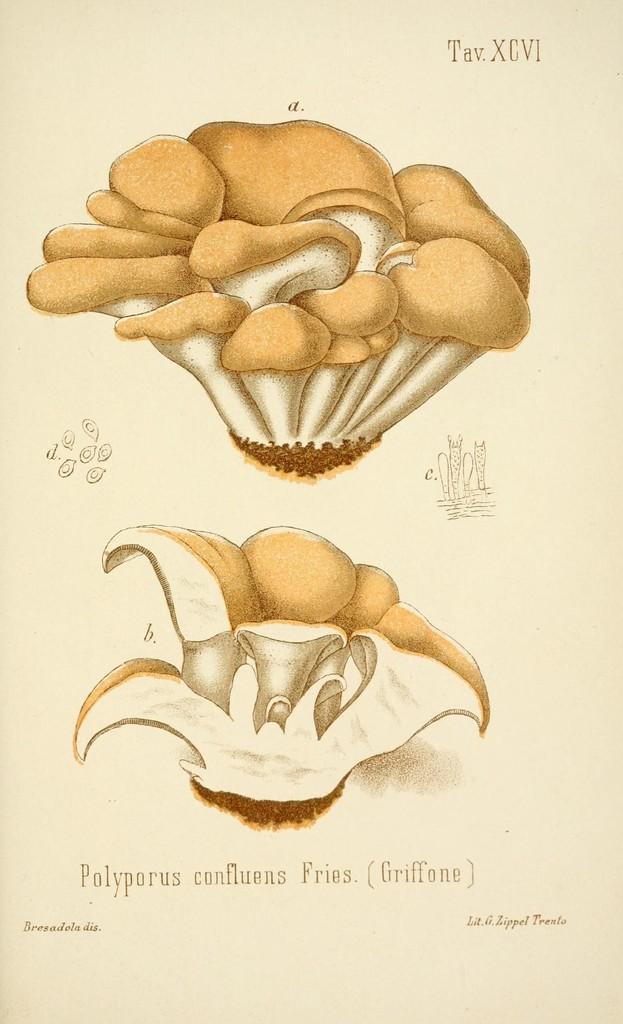Can you describe this image briefly? This is a picture of a paper, where there are photos and words on it. 